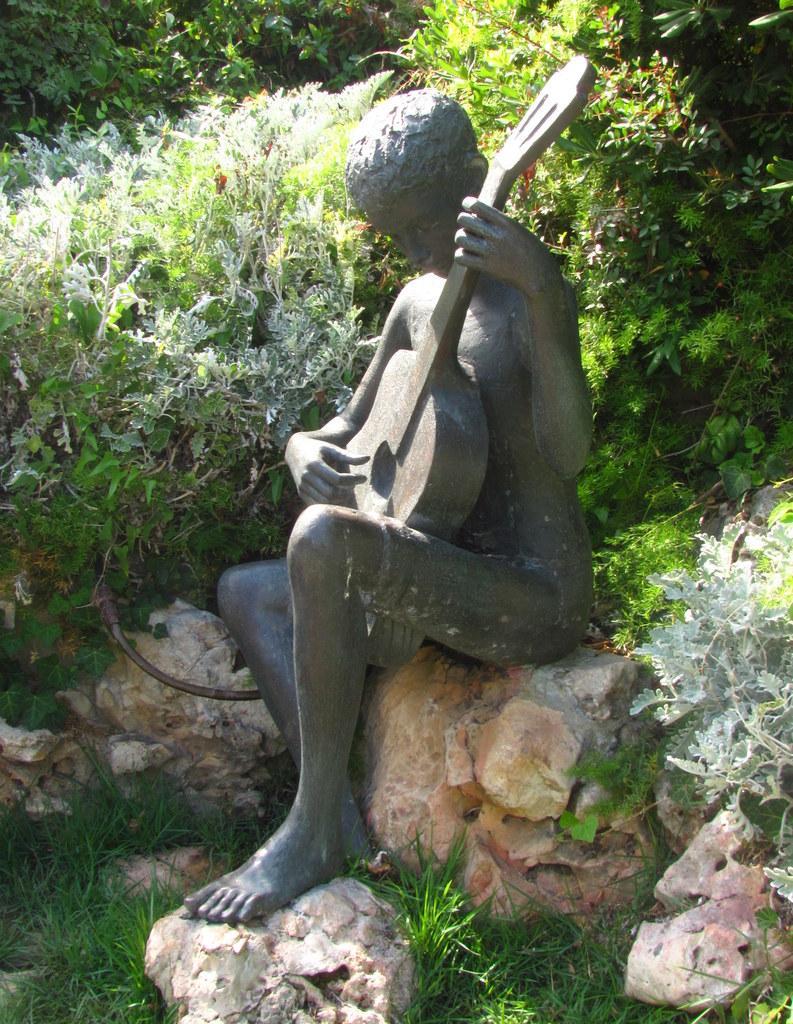Please provide a concise description of this image. In the foreground of this image, there is a sculpture sitting on the rock and on the bottom, there is the grass and a stone. In the background,, there are plants. 